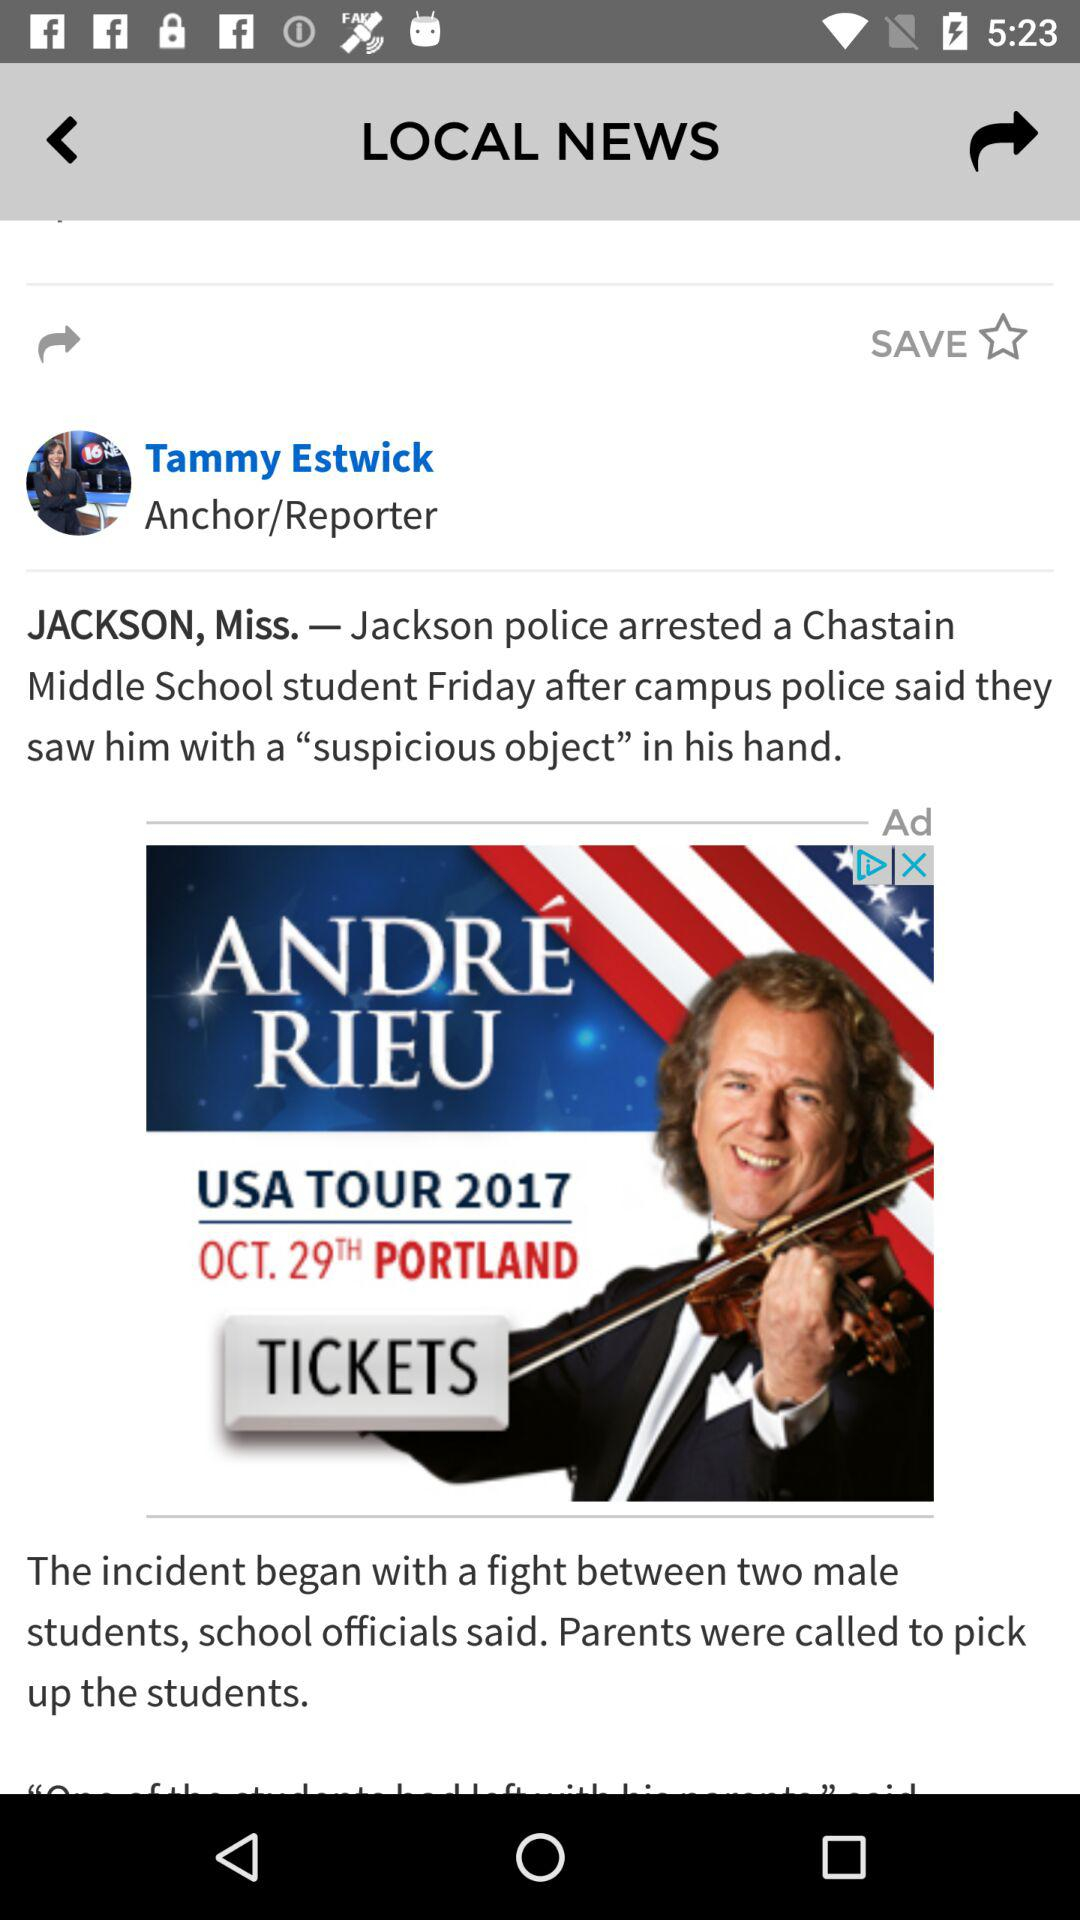What is the date of "USA Tour 2017"? The date is October 29. 